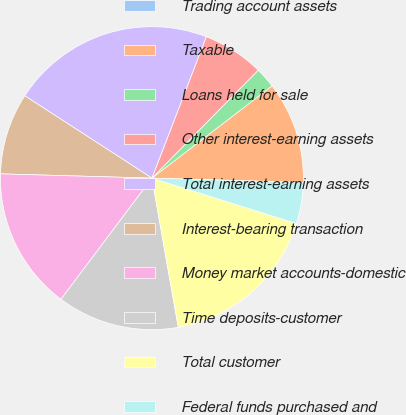Convert chart. <chart><loc_0><loc_0><loc_500><loc_500><pie_chart><fcel>Trading account assets<fcel>Taxable<fcel>Loans held for sale<fcel>Other interest-earning assets<fcel>Total interest-earning assets<fcel>Interest-bearing transaction<fcel>Money market accounts-domestic<fcel>Time deposits-customer<fcel>Total customer<fcel>Federal funds purchased and<nl><fcel>0.03%<fcel>10.87%<fcel>2.2%<fcel>6.53%<fcel>21.7%<fcel>8.7%<fcel>15.2%<fcel>13.03%<fcel>17.37%<fcel>4.37%<nl></chart> 